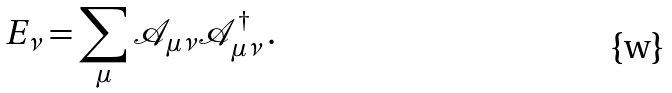Convert formula to latex. <formula><loc_0><loc_0><loc_500><loc_500>E _ { \nu } = \sum _ { \mu } { \mathcal { A } } _ { \mu \nu } { \mathcal { A } } _ { \mu \nu } ^ { \dagger } \, .</formula> 